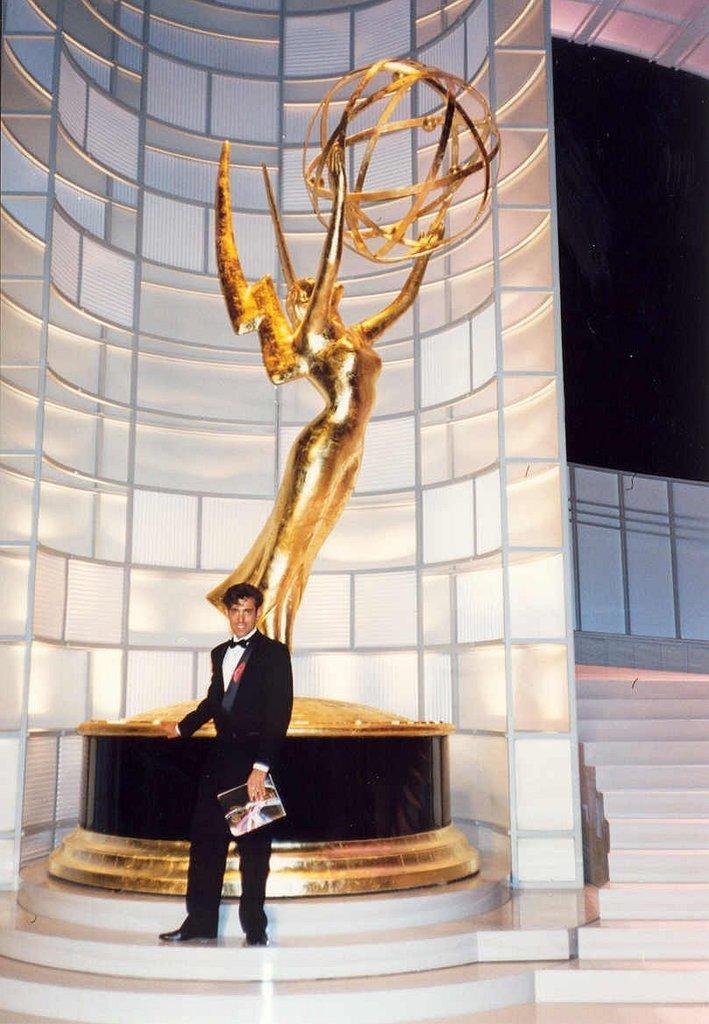What is the person in the image doing? The person is holding a book in the image. What is the person's posture in the image? The person is standing in the image. What can be seen behind the person? There is a sculpture and a wall behind the person. What architectural feature is present in the image? There is a staircase in the image. What is the color of the board in the image? There is a black color board in the image. How many roses are on the person's head in the image? There are no roses present in the image. Can you tell me how the person is preparing for their flight in the image? There is no indication of a flight or any preparations for a flight in the image. 